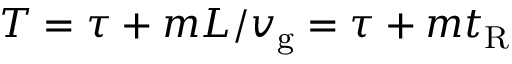Convert formula to latex. <formula><loc_0><loc_0><loc_500><loc_500>T = \tau + m L / v _ { g } = \tau + m t _ { R }</formula> 